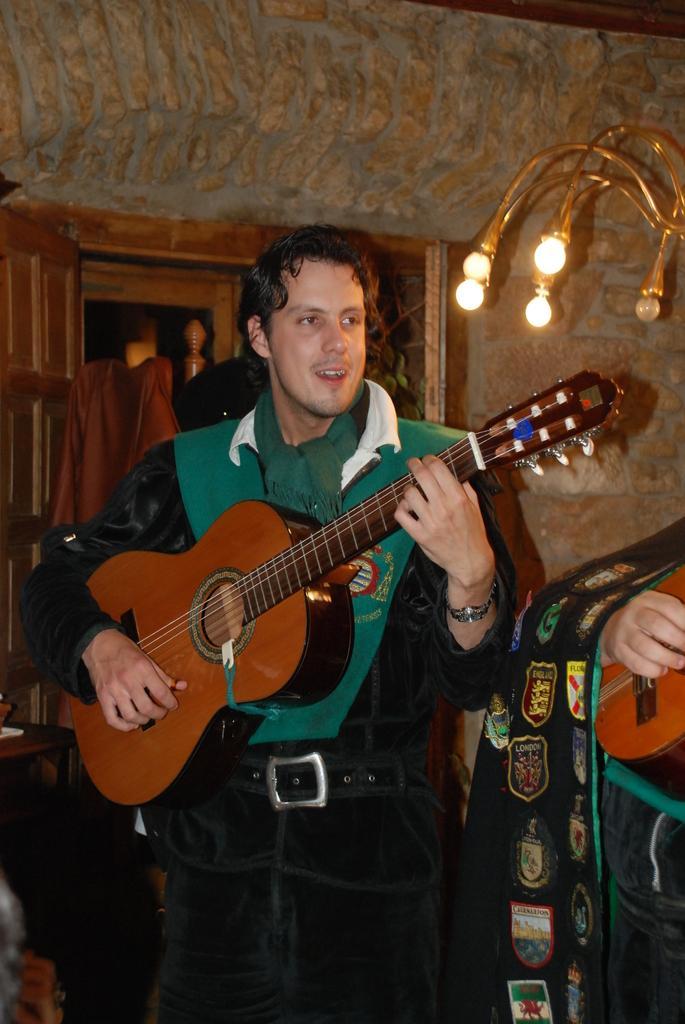Could you give a brief overview of what you see in this image? In this picture I can see a man playing guitar and I can see another human playing some instrument on the side and I can see lights on the right side and looks like a window in the back. 